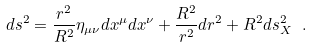<formula> <loc_0><loc_0><loc_500><loc_500>d s ^ { 2 } = \frac { r ^ { 2 } } { R ^ { 2 } } \eta _ { \mu \nu } d x ^ { \mu } d x ^ { \nu } + \frac { R ^ { 2 } } { r ^ { 2 } } d r ^ { 2 } + R ^ { 2 } d s _ { X } ^ { 2 } \ .</formula> 